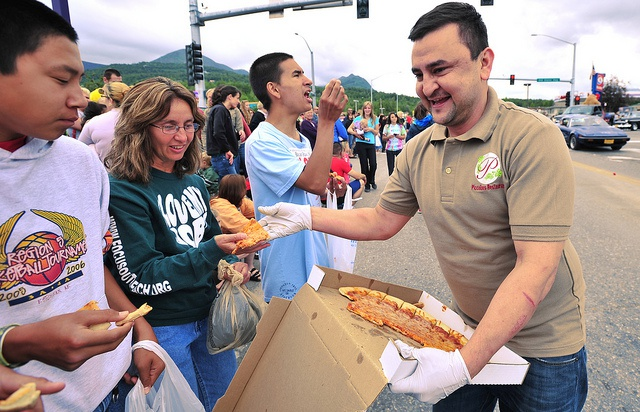Describe the objects in this image and their specific colors. I can see people in black, tan, and gray tones, people in black, lavender, and brown tones, people in black, blue, darkblue, and brown tones, people in black, lightblue, brown, and white tones, and pizza in black, tan, khaki, red, and salmon tones in this image. 